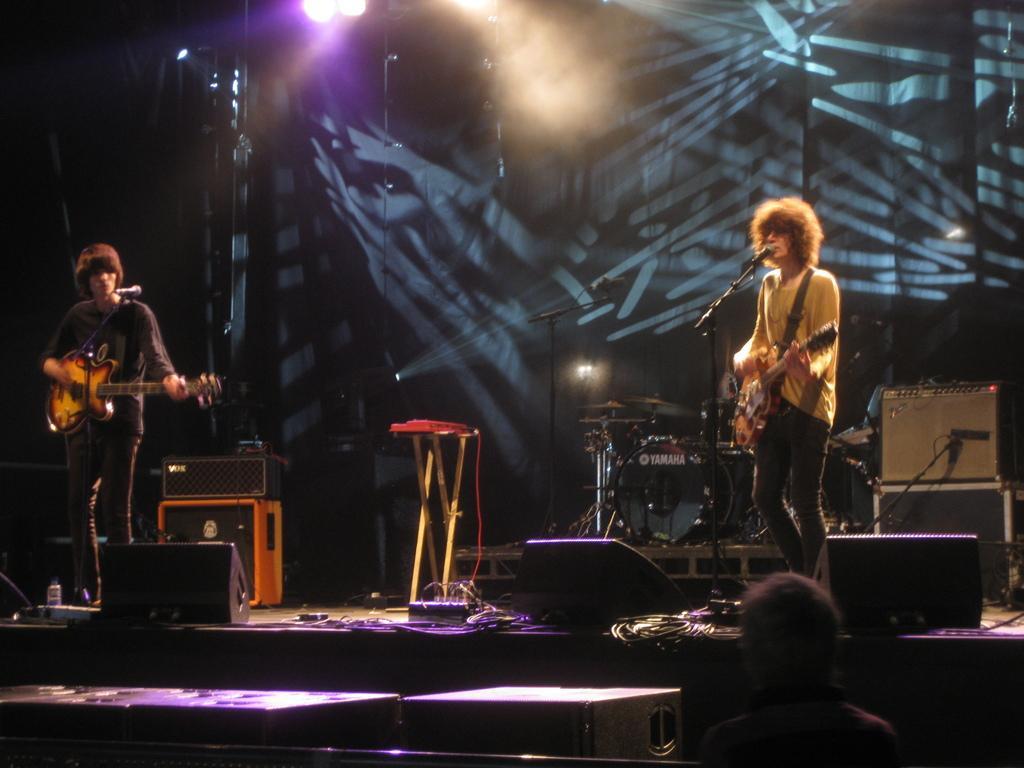How would you summarize this image in a sentence or two? In this picture there are two men who are playing guitar. There is a mic. There are some lights, bottle, wire and few other objects at the background. There is a person standing to the right. 